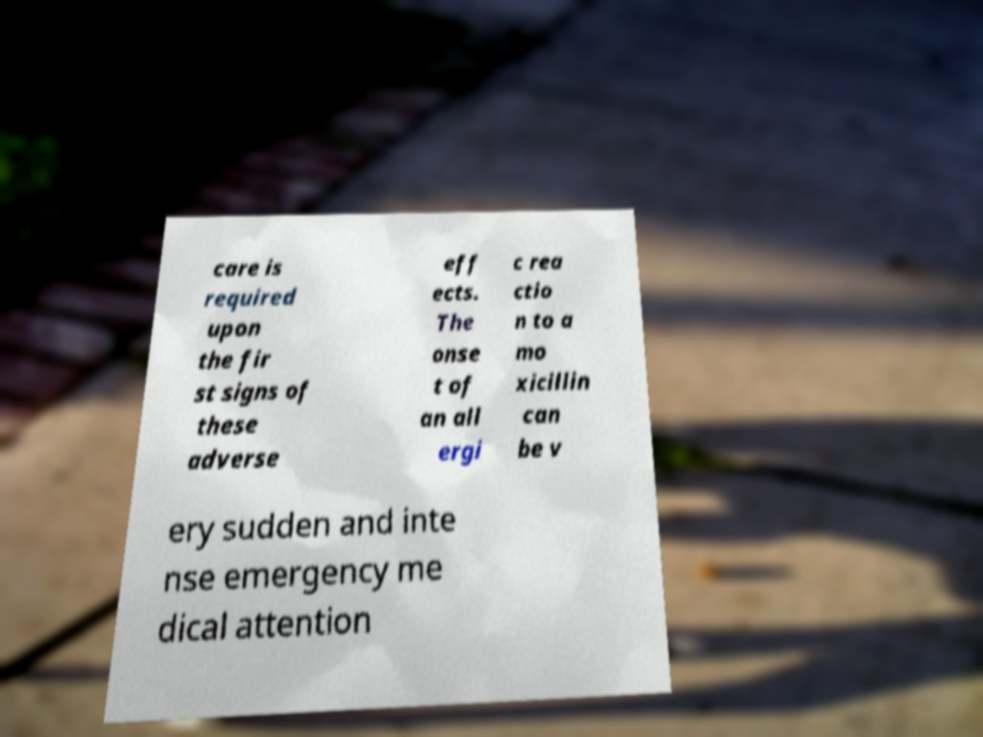Please identify and transcribe the text found in this image. care is required upon the fir st signs of these adverse eff ects. The onse t of an all ergi c rea ctio n to a mo xicillin can be v ery sudden and inte nse emergency me dical attention 